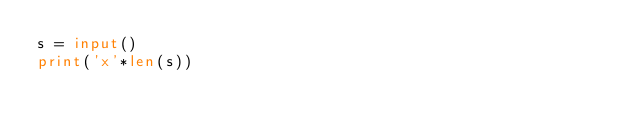<code> <loc_0><loc_0><loc_500><loc_500><_Python_>s = input()
print('x'*len(s))</code> 